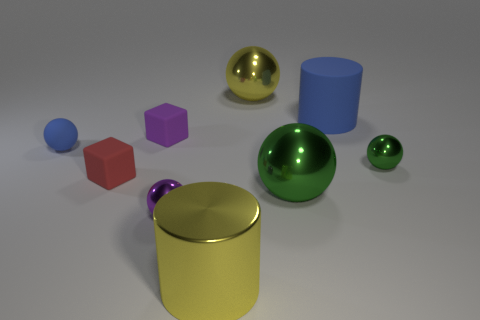What is the shape of the large shiny object that is both right of the large yellow shiny cylinder and in front of the tiny red block?
Your answer should be compact. Sphere. How many green things are either big metal cylinders or small metal balls?
Provide a succinct answer. 1. Does the block that is to the right of the tiny red object have the same color as the rubber cylinder?
Your answer should be compact. No. There is a shiny object that is on the left side of the big yellow thing that is in front of the yellow sphere; how big is it?
Your response must be concise. Small. There is a blue sphere that is the same size as the purple metallic ball; what material is it?
Offer a very short reply. Rubber. What number of other things are there of the same size as the purple block?
Give a very brief answer. 4. What number of blocks are yellow things or large blue matte objects?
Give a very brief answer. 0. Is there anything else that has the same material as the tiny red object?
Give a very brief answer. Yes. There is a blue object that is left of the cylinder that is on the right side of the large yellow object that is in front of the small green thing; what is it made of?
Your answer should be compact. Rubber. What material is the thing that is the same color as the big matte cylinder?
Your answer should be very brief. Rubber. 